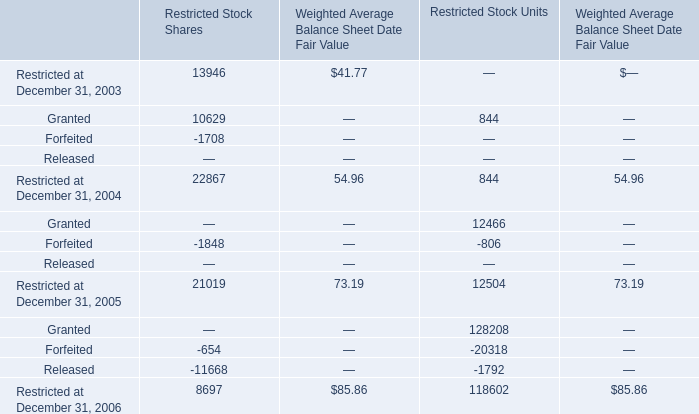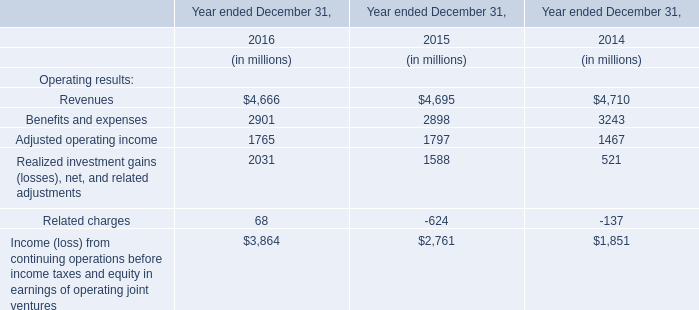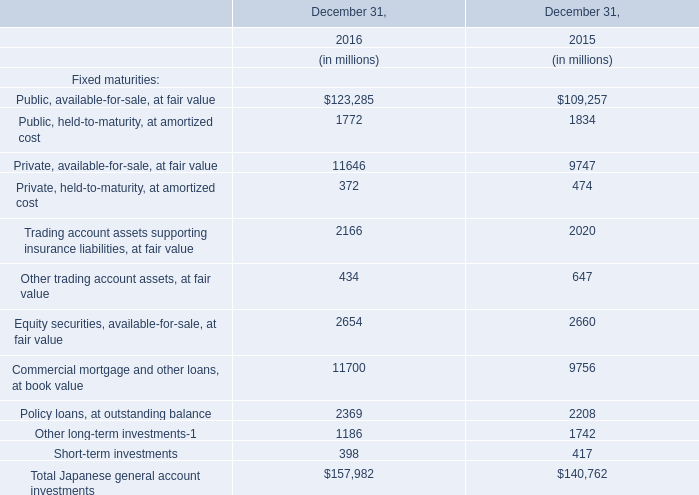in 2008 what was the ratio of the reduction of the personal injury expense and asbestos-related costs to the environmental and toxic tort expenses 
Computations: (82 / 7)
Answer: 11.71429. 